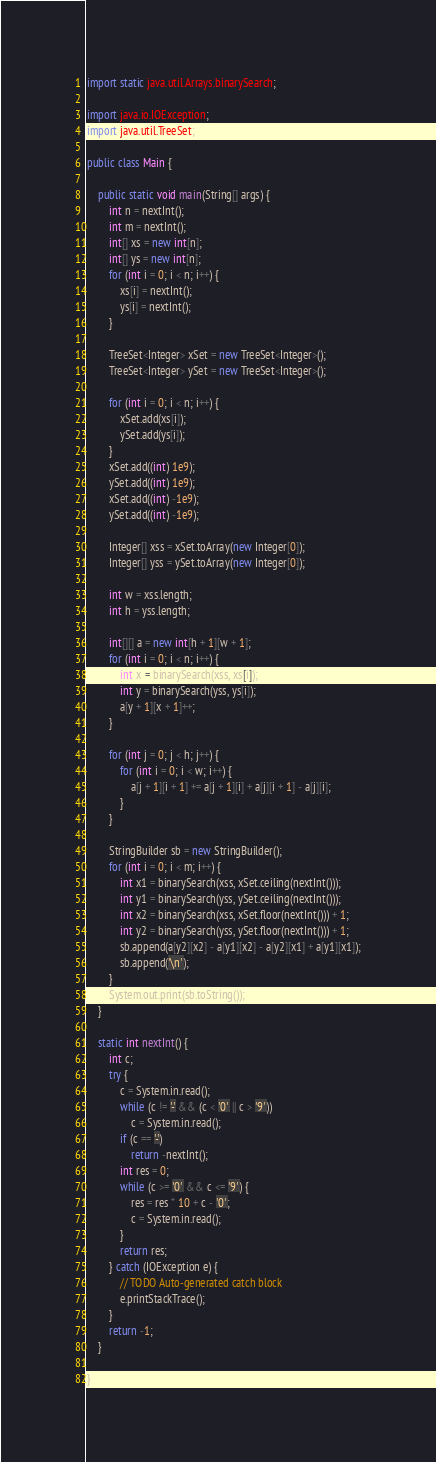Convert code to text. <code><loc_0><loc_0><loc_500><loc_500><_Java_>import static java.util.Arrays.binarySearch;

import java.io.IOException;
import java.util.TreeSet;

public class Main {

	public static void main(String[] args) {
		int n = nextInt();
		int m = nextInt();
		int[] xs = new int[n];
		int[] ys = new int[n];
		for (int i = 0; i < n; i++) {
			xs[i] = nextInt();
			ys[i] = nextInt();
		}

		TreeSet<Integer> xSet = new TreeSet<Integer>();
		TreeSet<Integer> ySet = new TreeSet<Integer>();

		for (int i = 0; i < n; i++) {
			xSet.add(xs[i]);
			ySet.add(ys[i]);
		}
		xSet.add((int) 1e9);
		ySet.add((int) 1e9);
		xSet.add((int) -1e9);
		ySet.add((int) -1e9);

		Integer[] xss = xSet.toArray(new Integer[0]);
		Integer[] yss = ySet.toArray(new Integer[0]);

		int w = xss.length;
		int h = yss.length;

		int[][] a = new int[h + 1][w + 1];
		for (int i = 0; i < n; i++) {
			int x = binarySearch(xss, xs[i]);
			int y = binarySearch(yss, ys[i]);
			a[y + 1][x + 1]++;
		}

		for (int j = 0; j < h; j++) {
			for (int i = 0; i < w; i++) {
				a[j + 1][i + 1] += a[j + 1][i] + a[j][i + 1] - a[j][i];
			}
		}

		StringBuilder sb = new StringBuilder();
		for (int i = 0; i < m; i++) {
			int x1 = binarySearch(xss, xSet.ceiling(nextInt()));
			int y1 = binarySearch(yss, ySet.ceiling(nextInt()));
			int x2 = binarySearch(xss, xSet.floor(nextInt())) + 1;
			int y2 = binarySearch(yss, ySet.floor(nextInt())) + 1;
			sb.append(a[y2][x2] - a[y1][x2] - a[y2][x1] + a[y1][x1]);
			sb.append('\n');
		}
		System.out.print(sb.toString());
	}

	static int nextInt() {
		int c;
		try {
			c = System.in.read();
			while (c != '-' && (c < '0' || c > '9'))
				c = System.in.read();
			if (c == '-')
				return -nextInt();
			int res = 0;
			while (c >= '0' && c <= '9') {
				res = res * 10 + c - '0';
				c = System.in.read();
			}
			return res;
		} catch (IOException e) {
			// TODO Auto-generated catch block
			e.printStackTrace();
		}
		return -1;
	}

}</code> 